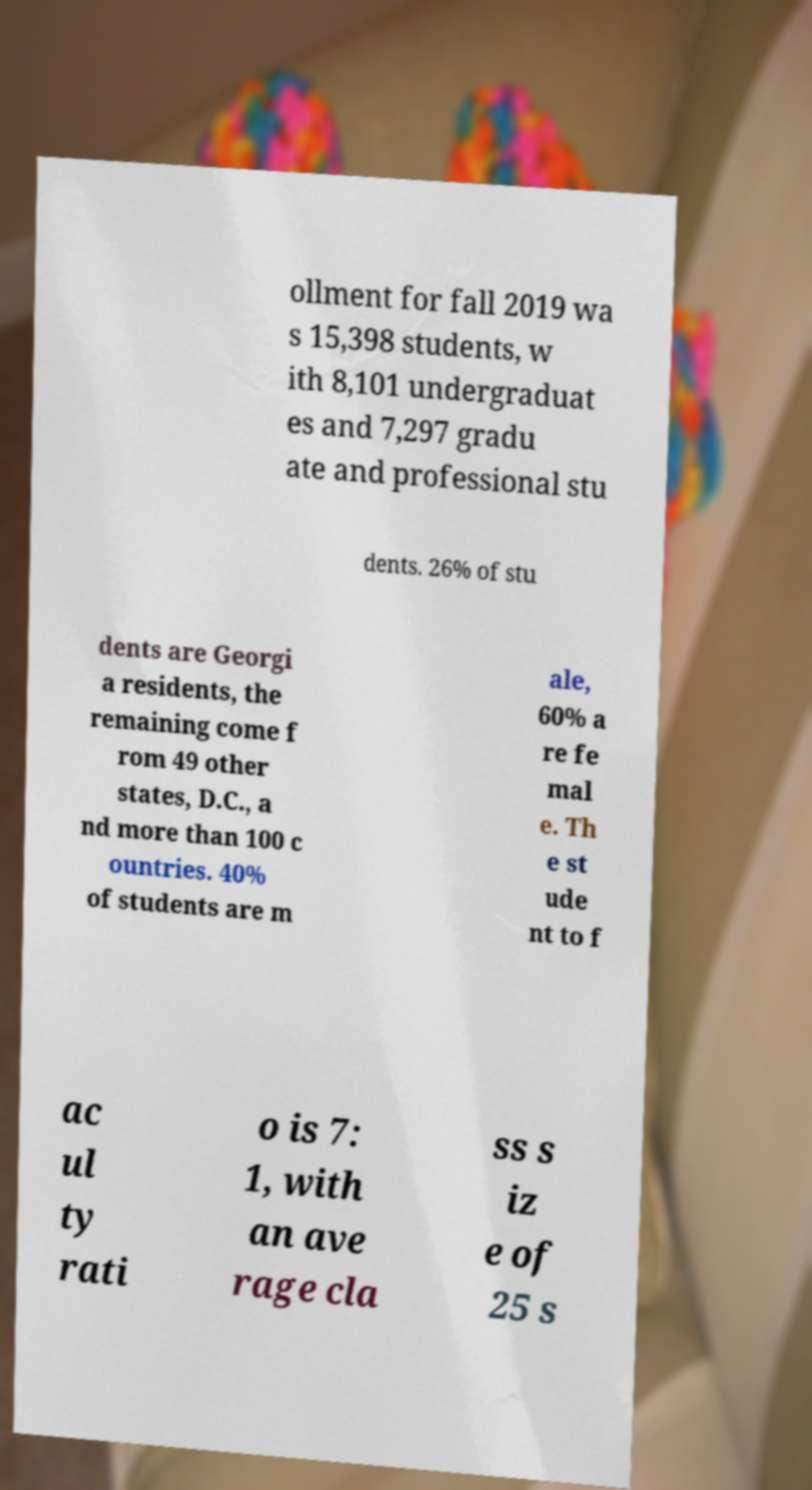What messages or text are displayed in this image? I need them in a readable, typed format. ollment for fall 2019 wa s 15,398 students, w ith 8,101 undergraduat es and 7,297 gradu ate and professional stu dents. 26% of stu dents are Georgi a residents, the remaining come f rom 49 other states, D.C., a nd more than 100 c ountries. 40% of students are m ale, 60% a re fe mal e. Th e st ude nt to f ac ul ty rati o is 7: 1, with an ave rage cla ss s iz e of 25 s 